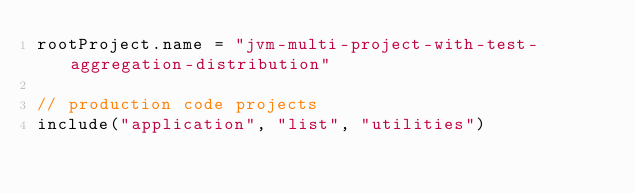Convert code to text. <code><loc_0><loc_0><loc_500><loc_500><_Kotlin_>rootProject.name = "jvm-multi-project-with-test-aggregation-distribution"

// production code projects
include("application", "list", "utilities")
</code> 